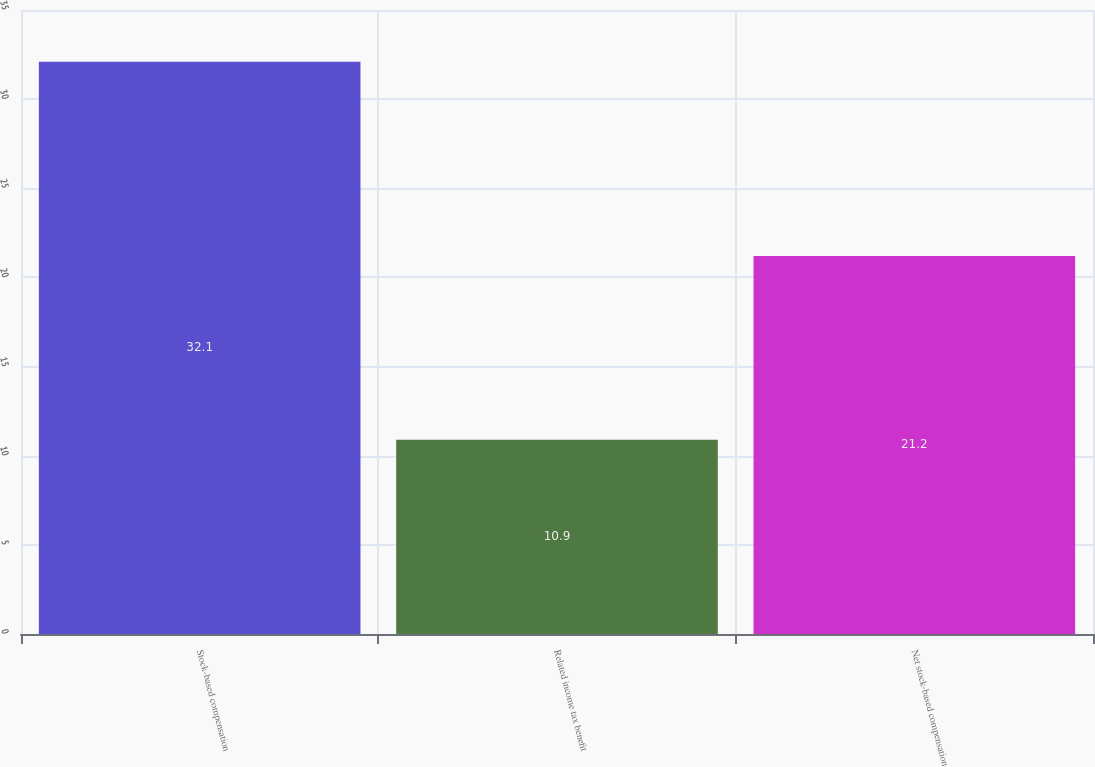<chart> <loc_0><loc_0><loc_500><loc_500><bar_chart><fcel>Stock-based compensation<fcel>Related income tax benefit<fcel>Net stock-based compensation<nl><fcel>32.1<fcel>10.9<fcel>21.2<nl></chart> 